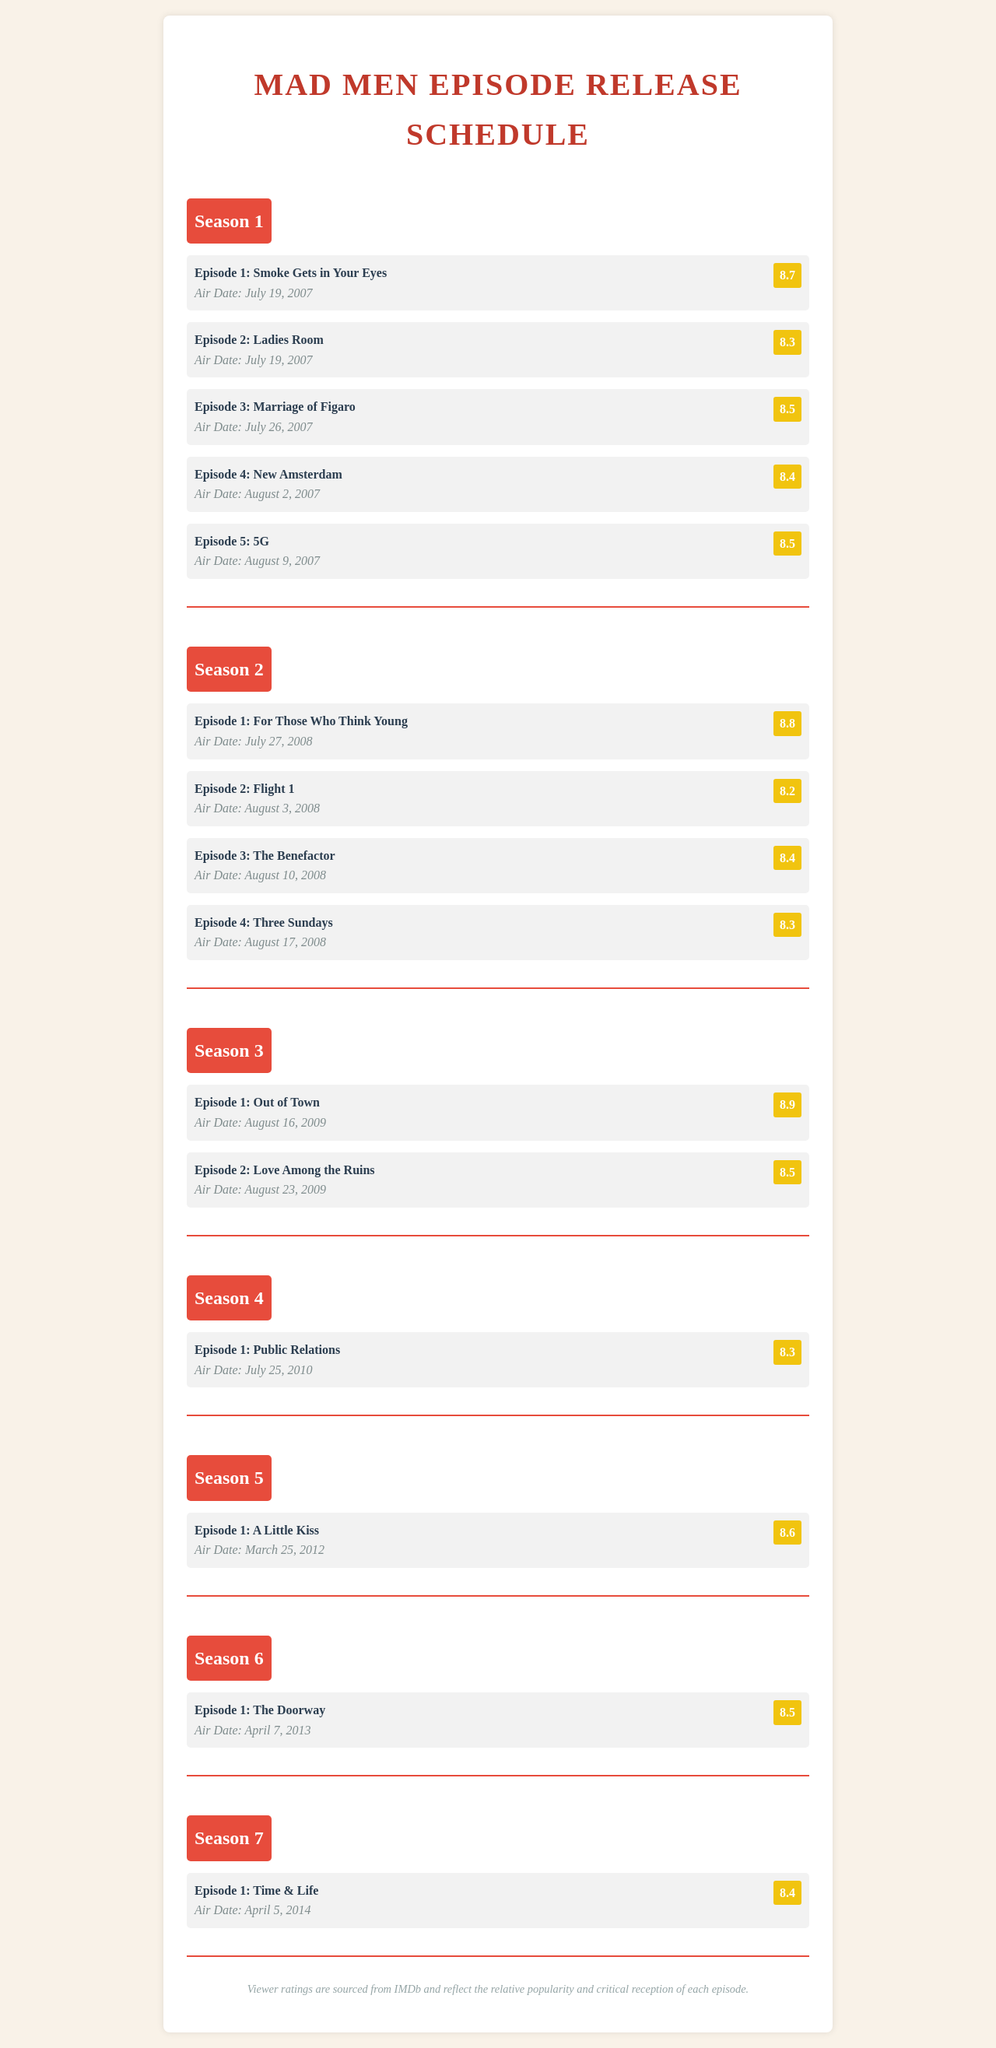What is the air date of Episode 1 of Season 1? The air date is specifically mentioned in the section for Season 1, Episode 1.
Answer: July 19, 2007 What was the viewer rating for Season 2, Episode 1? The rating is listed next to the episode title for Season 2, Episode 1.
Answer: 8.8 Which episode has the highest viewer rating? The document lists viewer ratings, and this requires comparing them to find the highest one.
Answer: Episode 1: Out of Town How many episodes are listed for Season 3? The number of episodes for Season 3 can be counted from the document.
Answer: 2 What is the title of Episode 4 in Season 2? The title is provided in the details for Season 2, Episode 4.
Answer: Three Sundays Which season has the earliest air date for Episode 1? The first episode of each season is compared to find which one aired first.
Answer: Season 1 What was the air date of the last episode of Season 7? While the document does not show the last episode, it requires knowledge of Season 7's total episodes which are understood from the structure.
Answer: April 5, 2014 Which episode from Season 6 has a rating of 8.5? This requires identifying the matching episode and rating in Season 6.
Answer: Episode 1: The Doorway 